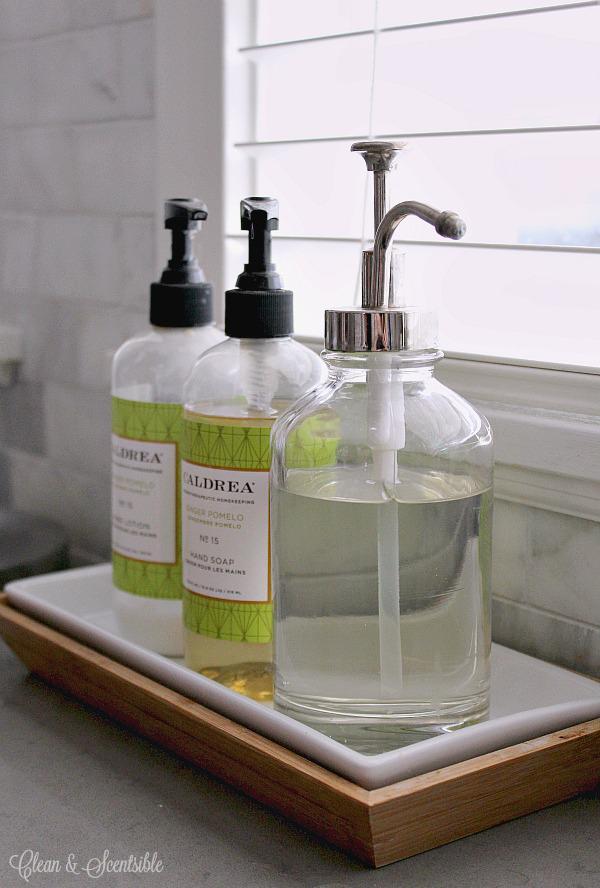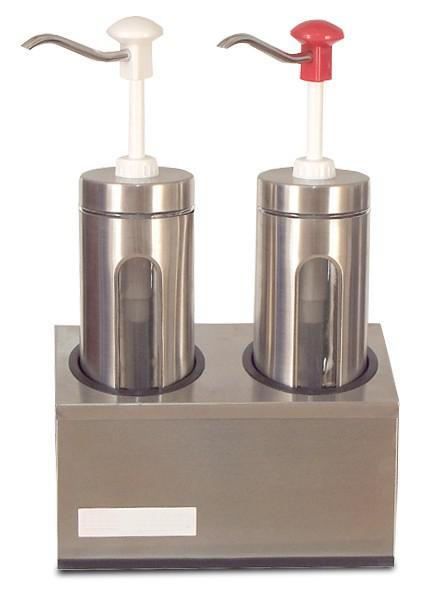The first image is the image on the left, the second image is the image on the right. Given the left and right images, does the statement "At least one image shows exactly three containers." hold true? Answer yes or no. Yes. 